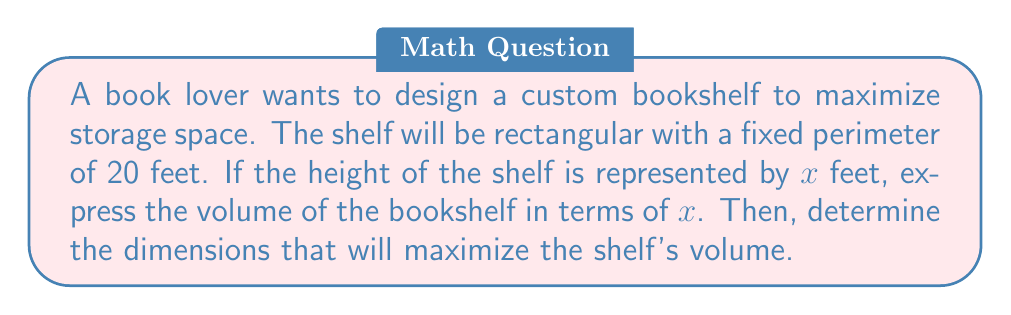Give your solution to this math problem. Let's approach this step-by-step:

1) First, we need to express the width of the shelf in terms of $x$. 
   Given that the perimeter is 20 feet, we can write:
   $2x + 2w = 20$, where $w$ is the width.
   Solving for $w$: $w = 10 - x$

2) Now, we can express the volume $V$ in terms of $x$:
   $V = x \cdot w \cdot d$, where $d$ is the depth of the shelf.
   Let's assume a standard depth of 1 foot for simplicity.
   
   $V = x(10-x)(1) = 10x - x^2$

3) To find the maximum volume, we need to find the vertex of this parabola.
   The vertex form of a quadratic equation is: $-a(x-h)^2 + k$
   where $(h,k)$ is the vertex.

4) Expanding our equation:
   $V = -x^2 + 10x = -(x^2 - 10x)$

5) Completing the square:
   $V = -(x^2 - 10x + 25 - 25) = -(x - 5)^2 + 25$

6) From this, we can see that the vertex is at $(5, 25)$.
   This means the volume is maximized when $x = 5$ feet.

7) To find the width at this point: $w = 10 - x = 10 - 5 = 5$ feet

Therefore, the optimal dimensions are 5 feet high and 5 feet wide.
Answer: The optimal dimensions for the bookshelf are 5 feet high and 5 feet wide, with a maximum volume of 25 cubic feet. 